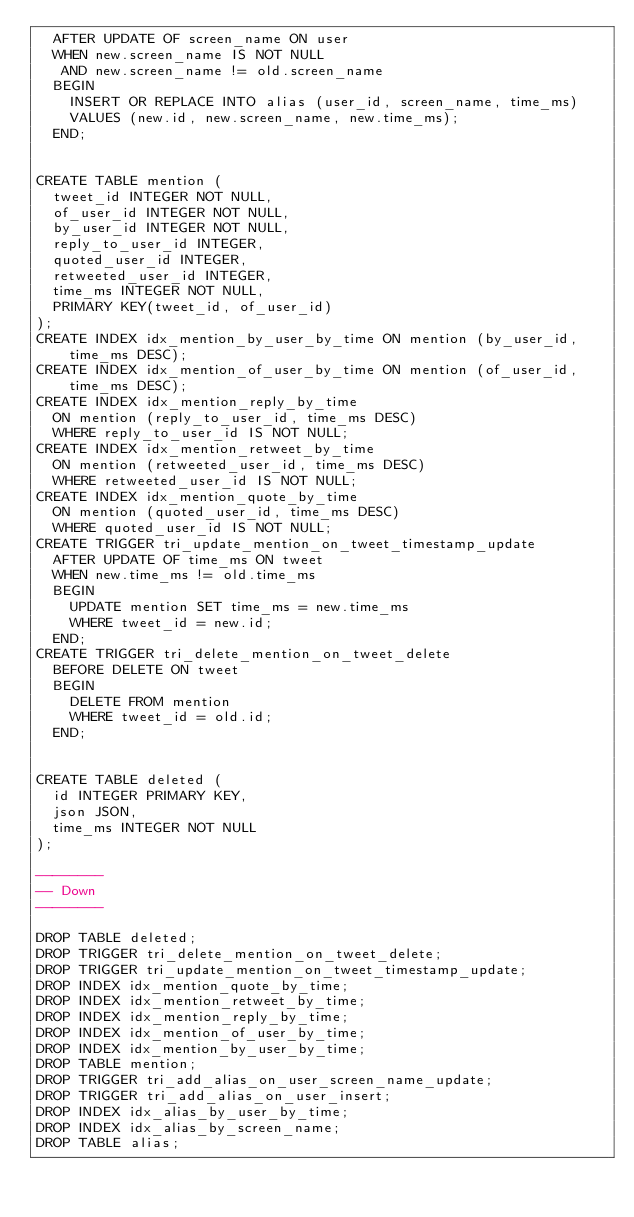Convert code to text. <code><loc_0><loc_0><loc_500><loc_500><_SQL_>  AFTER UPDATE OF screen_name ON user
  WHEN new.screen_name IS NOT NULL
   AND new.screen_name != old.screen_name
  BEGIN
    INSERT OR REPLACE INTO alias (user_id, screen_name, time_ms)
    VALUES (new.id, new.screen_name, new.time_ms);
  END;


CREATE TABLE mention (
  tweet_id INTEGER NOT NULL,
  of_user_id INTEGER NOT NULL,
  by_user_id INTEGER NOT NULL,
  reply_to_user_id INTEGER,
  quoted_user_id INTEGER,
  retweeted_user_id INTEGER,
  time_ms INTEGER NOT NULL,
  PRIMARY KEY(tweet_id, of_user_id)
);
CREATE INDEX idx_mention_by_user_by_time ON mention (by_user_id, time_ms DESC);
CREATE INDEX idx_mention_of_user_by_time ON mention (of_user_id, time_ms DESC);
CREATE INDEX idx_mention_reply_by_time
  ON mention (reply_to_user_id, time_ms DESC)
  WHERE reply_to_user_id IS NOT NULL;
CREATE INDEX idx_mention_retweet_by_time
  ON mention (retweeted_user_id, time_ms DESC)
  WHERE retweeted_user_id IS NOT NULL;
CREATE INDEX idx_mention_quote_by_time
  ON mention (quoted_user_id, time_ms DESC)
  WHERE quoted_user_id IS NOT NULL;
CREATE TRIGGER tri_update_mention_on_tweet_timestamp_update
  AFTER UPDATE OF time_ms ON tweet
  WHEN new.time_ms != old.time_ms
  BEGIN
    UPDATE mention SET time_ms = new.time_ms
    WHERE tweet_id = new.id;
  END;
CREATE TRIGGER tri_delete_mention_on_tweet_delete
  BEFORE DELETE ON tweet
  BEGIN
    DELETE FROM mention
    WHERE tweet_id = old.id;
  END;


CREATE TABLE deleted (
  id INTEGER PRIMARY KEY,
  json JSON,
  time_ms INTEGER NOT NULL
);

--------
-- Down
--------

DROP TABLE deleted;
DROP TRIGGER tri_delete_mention_on_tweet_delete;
DROP TRIGGER tri_update_mention_on_tweet_timestamp_update;
DROP INDEX idx_mention_quote_by_time;
DROP INDEX idx_mention_retweet_by_time;
DROP INDEX idx_mention_reply_by_time;
DROP INDEX idx_mention_of_user_by_time;
DROP INDEX idx_mention_by_user_by_time;
DROP TABLE mention;
DROP TRIGGER tri_add_alias_on_user_screen_name_update;
DROP TRIGGER tri_add_alias_on_user_insert;
DROP INDEX idx_alias_by_user_by_time;
DROP INDEX idx_alias_by_screen_name;
DROP TABLE alias;
</code> 